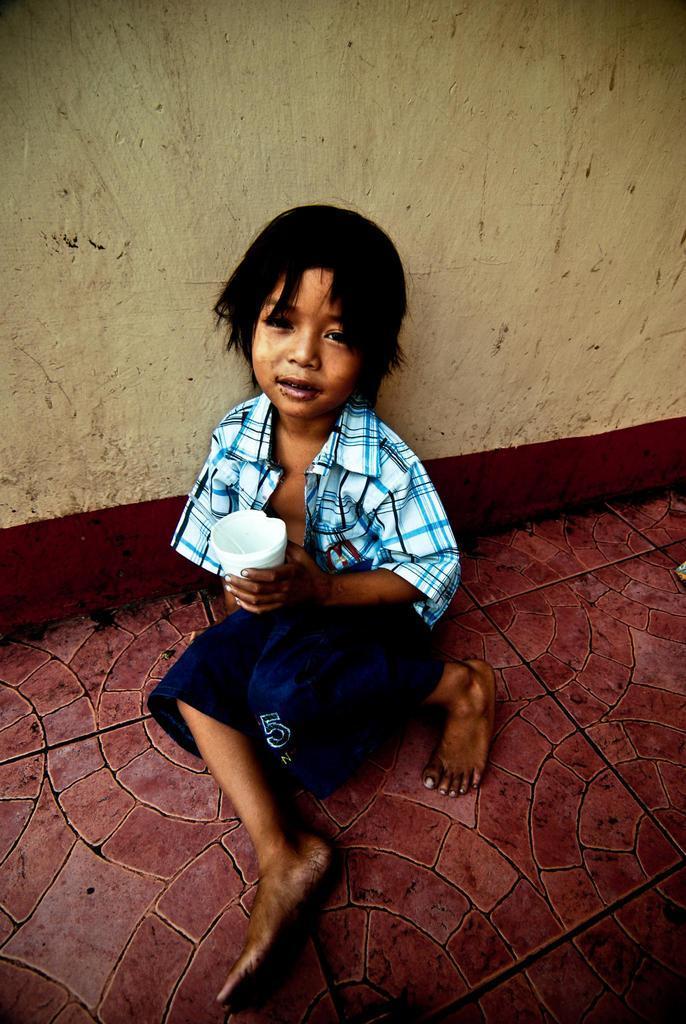How would you summarize this image in a sentence or two? In this image I can see in the middle a boy is sitting, he is wearing a shirt, short and also he is holding a glass with his hand. 